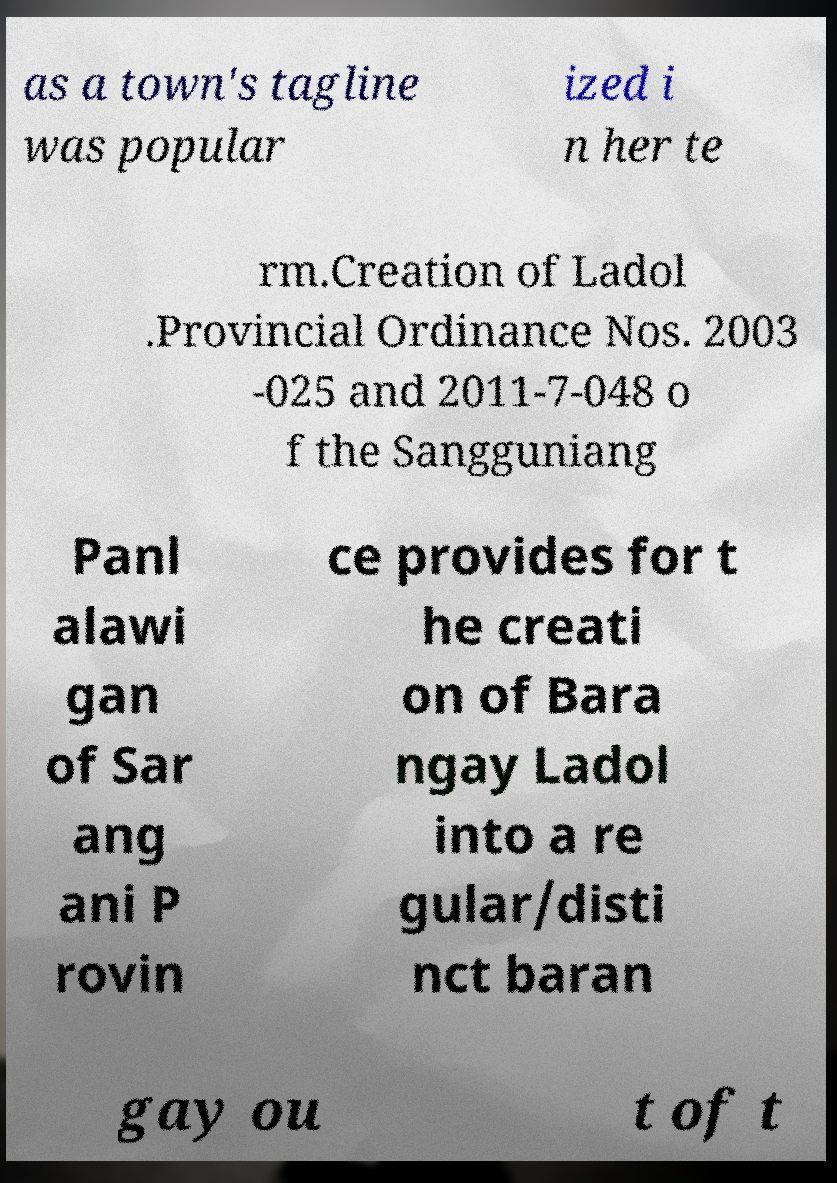There's text embedded in this image that I need extracted. Can you transcribe it verbatim? as a town's tagline was popular ized i n her te rm.Creation of Ladol .Provincial Ordinance Nos. 2003 -025 and 2011-7-048 o f the Sangguniang Panl alawi gan of Sar ang ani P rovin ce provides for t he creati on of Bara ngay Ladol into a re gular/disti nct baran gay ou t of t 